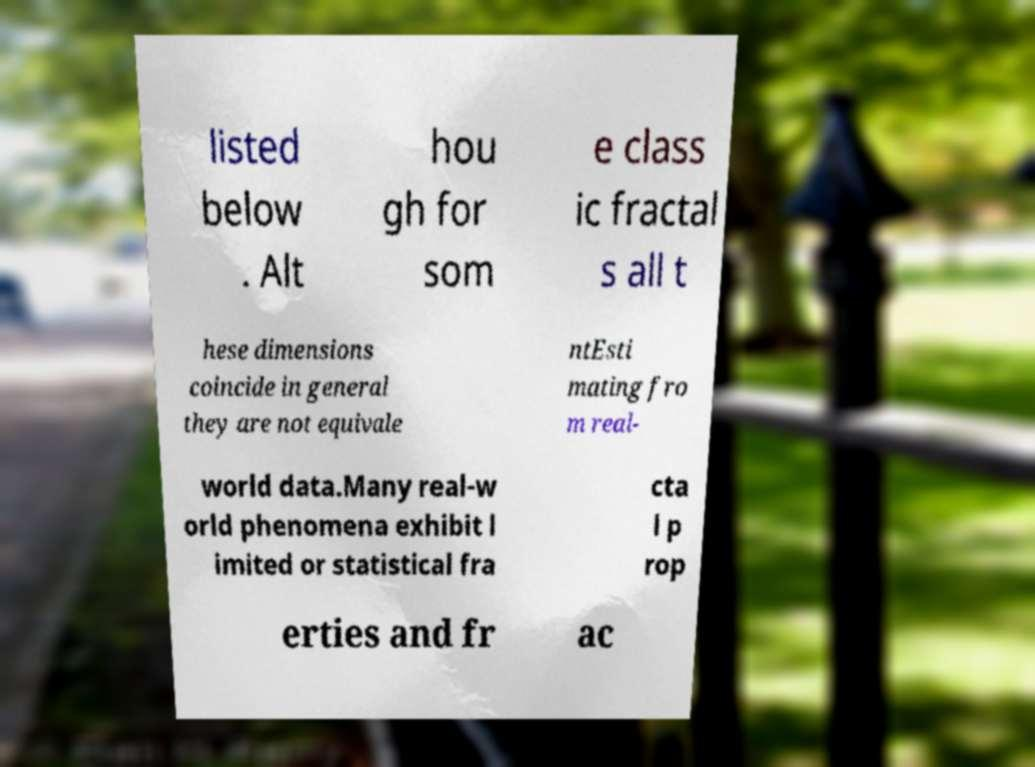What messages or text are displayed in this image? I need them in a readable, typed format. listed below . Alt hou gh for som e class ic fractal s all t hese dimensions coincide in general they are not equivale ntEsti mating fro m real- world data.Many real-w orld phenomena exhibit l imited or statistical fra cta l p rop erties and fr ac 